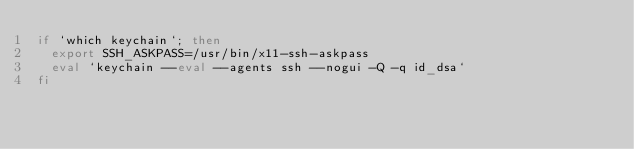<code> <loc_0><loc_0><loc_500><loc_500><_Bash_>if `which keychain`; then
  export SSH_ASKPASS=/usr/bin/x11-ssh-askpass
  eval `keychain --eval --agents ssh --nogui -Q -q id_dsa`
fi

</code> 